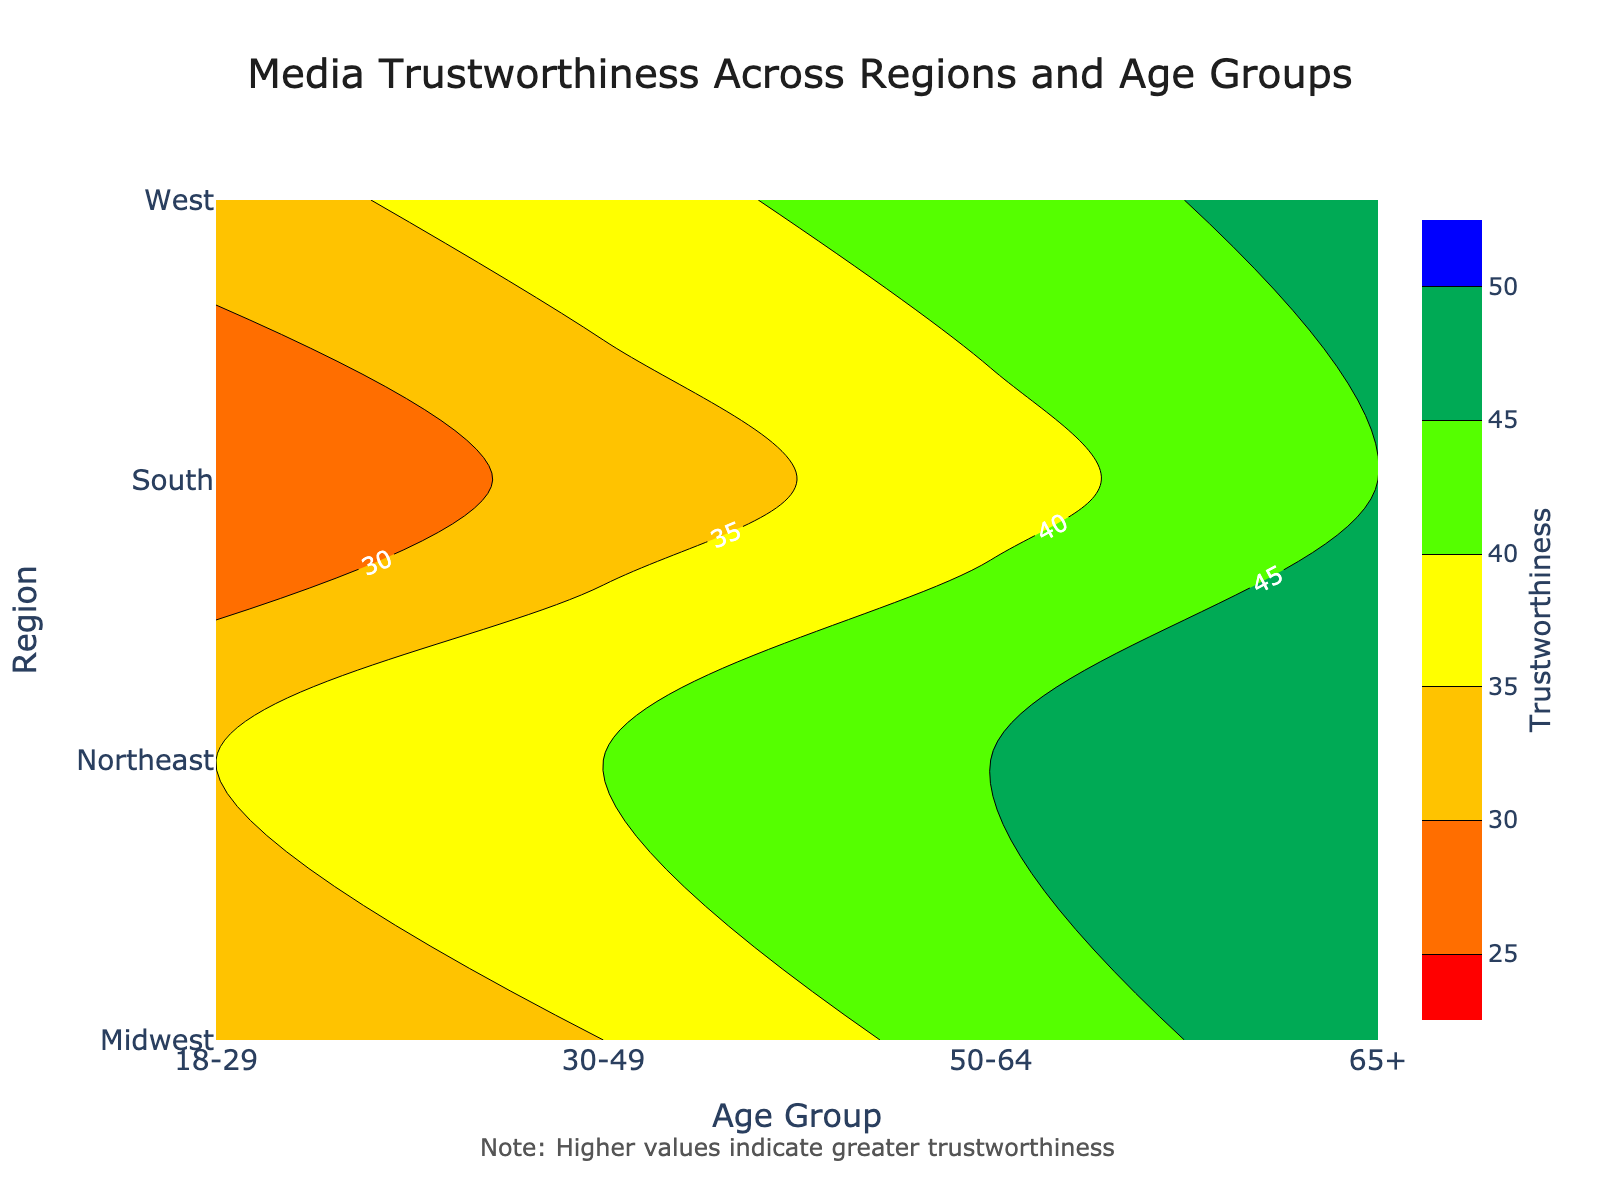What is the title of the figure? The title of the figure is located at the top center of the plot. It provides an overview of what the figure represents. From the figure, we can see that the title is "Media Trustworthiness Across Regions and Age Groups".
Answer: Media Trustworthiness Across Regions and Age Groups What is the color scale used in the plot? The color scale is a range that goes from red to blue, with red representing lower values and blue representing higher values of trustworthiness. The intermediary colors (orange, yellow, green) bridge the gap between these extremes.
Answer: Red to blue Which region has the highest trustworthiness in the age group 18-29? To find this, look at the contour lines or color gradients corresponding to the age group 18-29 along the x-axis and see which region has the highest value in terms of color. The West has the highest value of 33 in that age group.
Answer: West How does the trustworthiness of the South for the age group 65+ compare to the Northeast for the same age group? Locate the values for the South and Northeast along the y-axis, both corresponding to the age group 65+. The South has a trustworthiness value of 45, while the Northeast has a value of 50. Thus, the Northeast has a higher trustworthiness score for this age group.
Answer: Northeast is higher What is the general trend in trustworthiness across age groups in the Midwest? Observe the Midwest region along the y-axis and check the trustworthiness values across all age groups (18-29, 30-49, 50-64, 65+). The values are 30, 35, 42, and 48, respectively, showing a general increase in trustworthiness with age.
Answer: Increases with age Among the regions shown, which one has the lowest trustworthiness rating across any age group? To find the lowest trustworthiness rating, look across the entire contour plot for the lowest element. The South has the lowest rating of 25 in the age group 18-29.
Answer: South for age group 18-29 What's the average trustworthiness score for the West region across all age groups? Sum the trustworthiness values for the West region across all age groups and divide by the number of age groups. The values are 33, 38, 43, and 47; their sum is 161. Dividing by 4 gives an average of 40.25.
Answer: 40.25 Which age group shows the greatest range in trustworthiness values across the regions? Calculate the range (max - min) of trustworthiness values for each age group across all regions. For 18-29: (35-25=10), for 30-49: (40-32=8), for 50-64: (45-38=7), for 65+: (50-45=5). The age group 18-29 has the greatest range.
Answer: 18-29 Is there a region where trustworthiness values are generally consistent across age groups? Check the differences in trustworthiness values across age groups for each region. The Midwest’s values are 30, 35, 42, and 48, showing the smallest variations compared to other regions. The values increase but not as sharply as in other regions.
Answer: Midwest In which age group does the Northeast have its highest trustworthiness value? Look at the Northeast row and check the trustworthiness values for each age group (18-29, 30-49, 50-64, 65+). The value for the 65+ age group is 50, which is the highest.
Answer: 65+ 